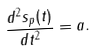<formula> <loc_0><loc_0><loc_500><loc_500>\frac { d ^ { 2 } { s } _ { p } ( t ) } { d t ^ { 2 } } = { a } .</formula> 